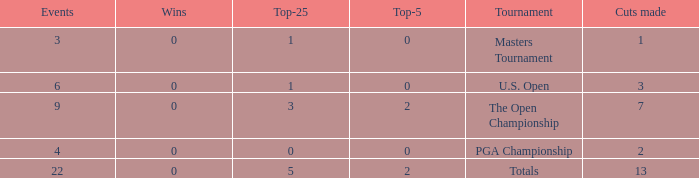What is the fewest wins for Thomas in events he had entered exactly 9 times? 0.0. 